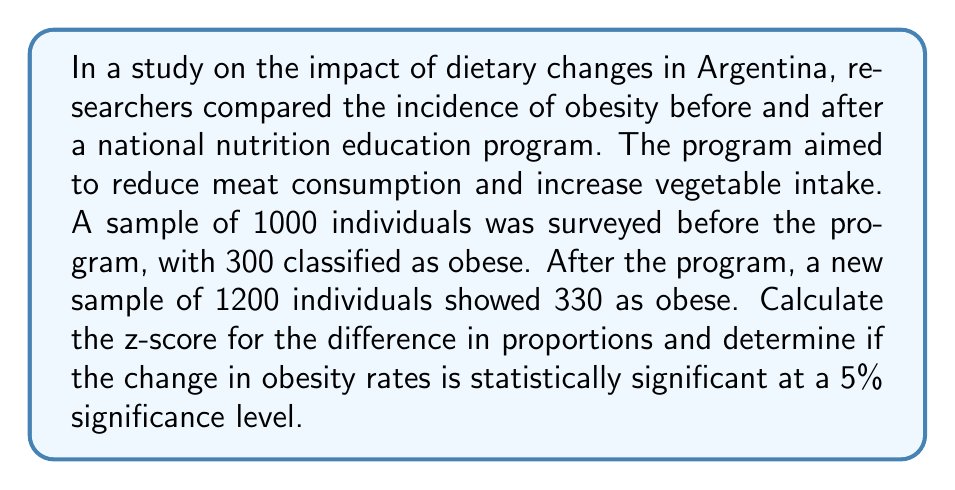What is the answer to this math problem? To solve this problem, we'll use the two-proportion z-test. We'll follow these steps:

1. Define the null and alternative hypotheses:
   $H_0: p_1 = p_2$ (no difference in proportions)
   $H_a: p_1 \neq p_2$ (there is a difference in proportions)

2. Calculate the sample proportions:
   $\hat{p}_1 = \frac{300}{1000} = 0.3$
   $\hat{p}_2 = \frac{330}{1200} = 0.275$

3. Calculate the pooled proportion:
   $$\hat{p} = \frac{X_1 + X_2}{n_1 + n_2} = \frac{300 + 330}{1000 + 1200} = \frac{630}{2200} = 0.2864$$

4. Calculate the standard error of the difference in proportions:
   $$SE = \sqrt{\hat{p}(1-\hat{p})(\frac{1}{n_1} + \frac{1}{n_2})}$$
   $$SE = \sqrt{0.2864(1-0.2864)(\frac{1}{1000} + \frac{1}{1200})} = 0.0196$$

5. Calculate the z-score:
   $$z = \frac{\hat{p}_1 - \hat{p}_2}{SE} = \frac{0.3 - 0.275}{0.0196} = 1.28$$

6. Determine the critical value:
   For a 5% significance level (two-tailed test), the critical z-value is ±1.96.

7. Compare the calculated z-score with the critical value:
   Since |1.28| < 1.96, we fail to reject the null hypothesis.
Answer: The z-score is 1.28. At a 5% significance level, the change in obesity rates is not statistically significant, as the calculated z-score (1.28) does not exceed the critical value (±1.96). 